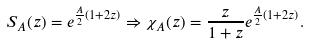Convert formula to latex. <formula><loc_0><loc_0><loc_500><loc_500>S _ { A } ( z ) = e ^ { \frac { A } { 2 } ( 1 + 2 z ) } \Rightarrow \chi _ { A } ( z ) = \frac { z } { 1 + z } e ^ { \frac { A } { 2 } ( 1 + 2 z ) } .</formula> 